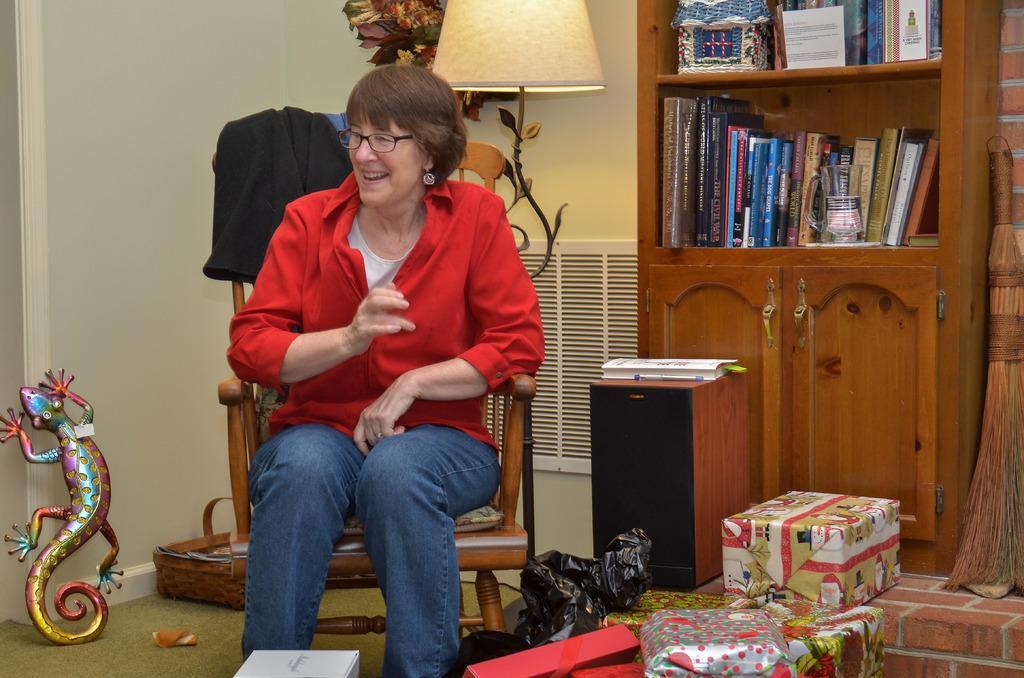How would you summarize this image in a sentence or two? In the left side of the image we can see a toy and a basket placed on the floor. In the center of the image we can see a woman sitting on a chair, group of boxes and a cover placed on the surface, On the right side of the image we can see a book and pen placed on a speaker, a group of books and some objects placed on racks, a cupboard and a broom placed on the floor. In the background, we can see a grill and some flowers. At the top of the image we can see a lamp. 